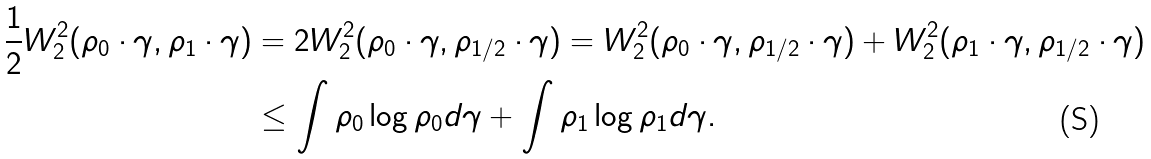Convert formula to latex. <formula><loc_0><loc_0><loc_500><loc_500>\frac { 1 } { 2 } W ^ { 2 } _ { 2 } ( \rho _ { 0 } \cdot \gamma , \rho _ { 1 } \cdot \gamma ) & = 2 W ^ { 2 } _ { 2 } ( \rho _ { 0 } \cdot \gamma , \rho _ { 1 / 2 } \cdot \gamma ) = W ^ { 2 } _ { 2 } ( \rho _ { 0 } \cdot \gamma , \rho _ { 1 / 2 } \cdot \gamma ) + W ^ { 2 } _ { 2 } ( \rho _ { 1 } \cdot \gamma , \rho _ { 1 / 2 } \cdot \gamma ) \\ & \leq \int \rho _ { 0 } \log \rho _ { 0 } d \gamma + \int \rho _ { 1 } \log \rho _ { 1 } d \gamma .</formula> 